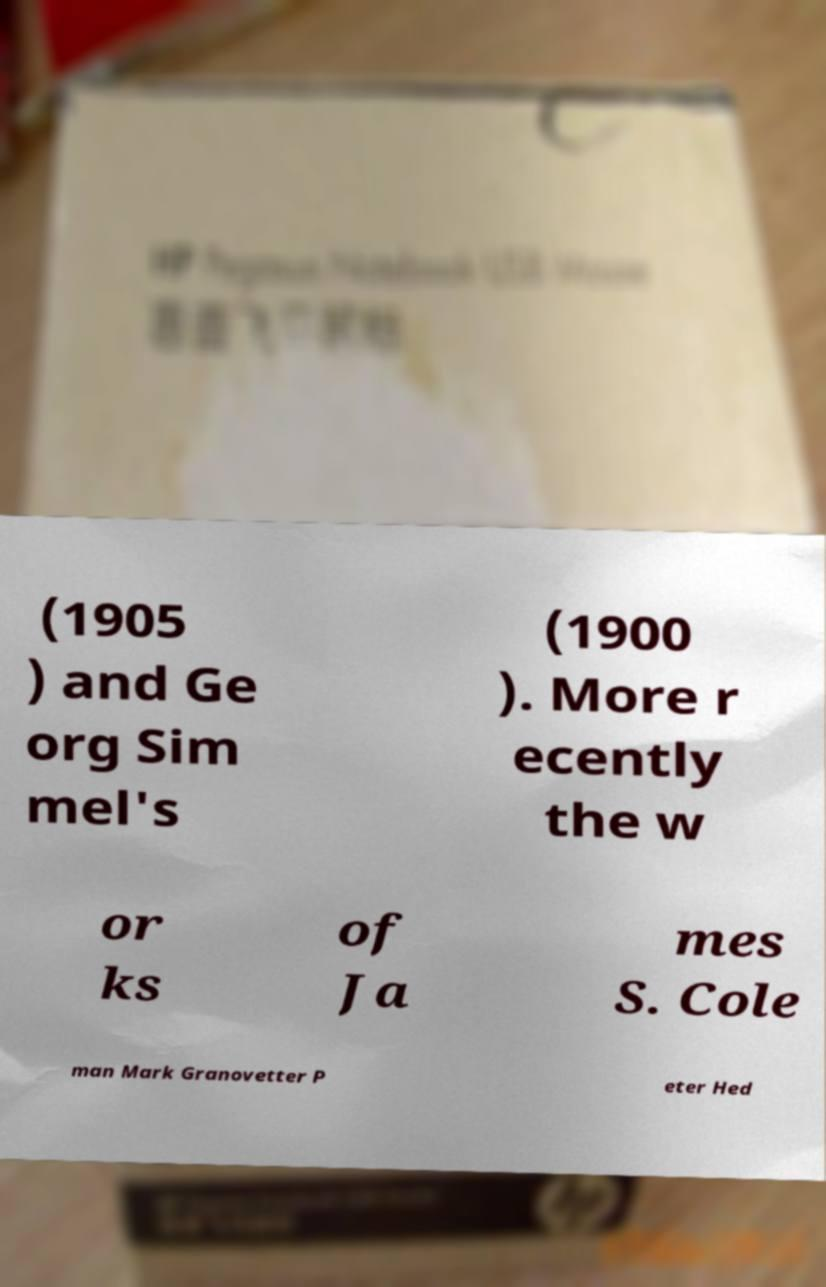There's text embedded in this image that I need extracted. Can you transcribe it verbatim? (1905 ) and Ge org Sim mel's (1900 ). More r ecently the w or ks of Ja mes S. Cole man Mark Granovetter P eter Hed 